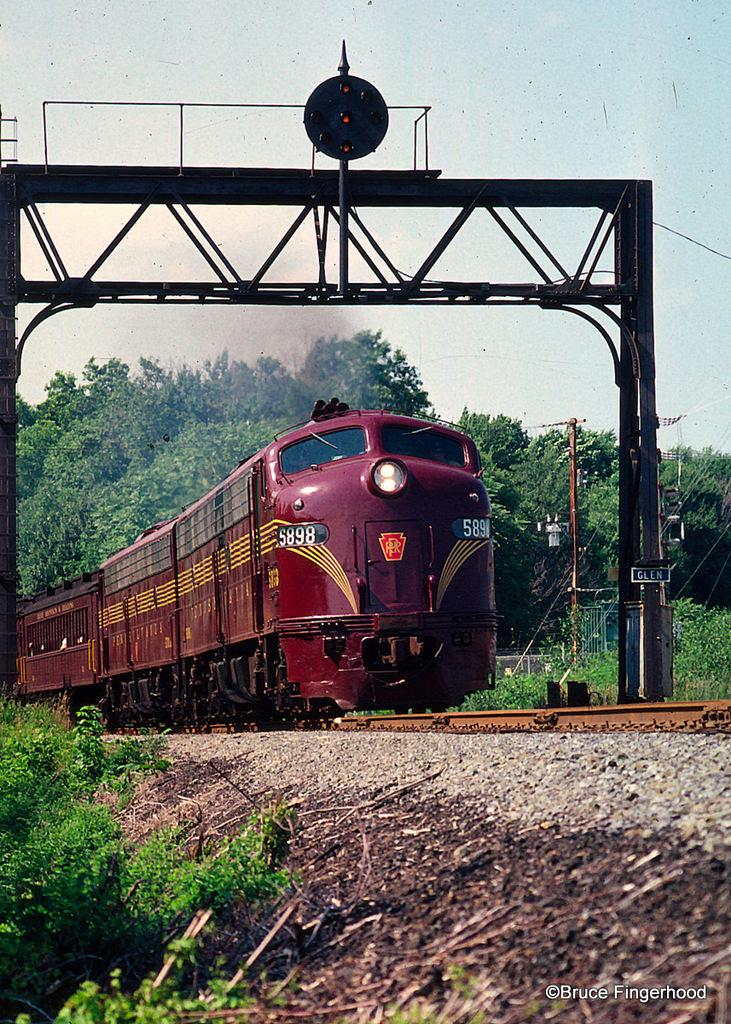What type of vehicle is in the image? There is a red train in the image. What is the train positioned on? The train is on tracks. What type of vegetation is at the bottom of the image? There are small plants at the bottom of the image. What can be seen in the background of the image? There are many trees in the background of the image. What type of trousers is the train wearing in the image? Trains do not wear trousers, as they are inanimate objects. The question is not relevant to the image. 